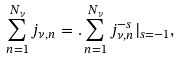Convert formula to latex. <formula><loc_0><loc_0><loc_500><loc_500>\sum _ { n = 1 } ^ { N _ { \nu } } j _ { \nu , n } = . \sum _ { n = 1 } ^ { N _ { \nu } } j _ { \nu , n } ^ { - s } | _ { s = - 1 } ,</formula> 